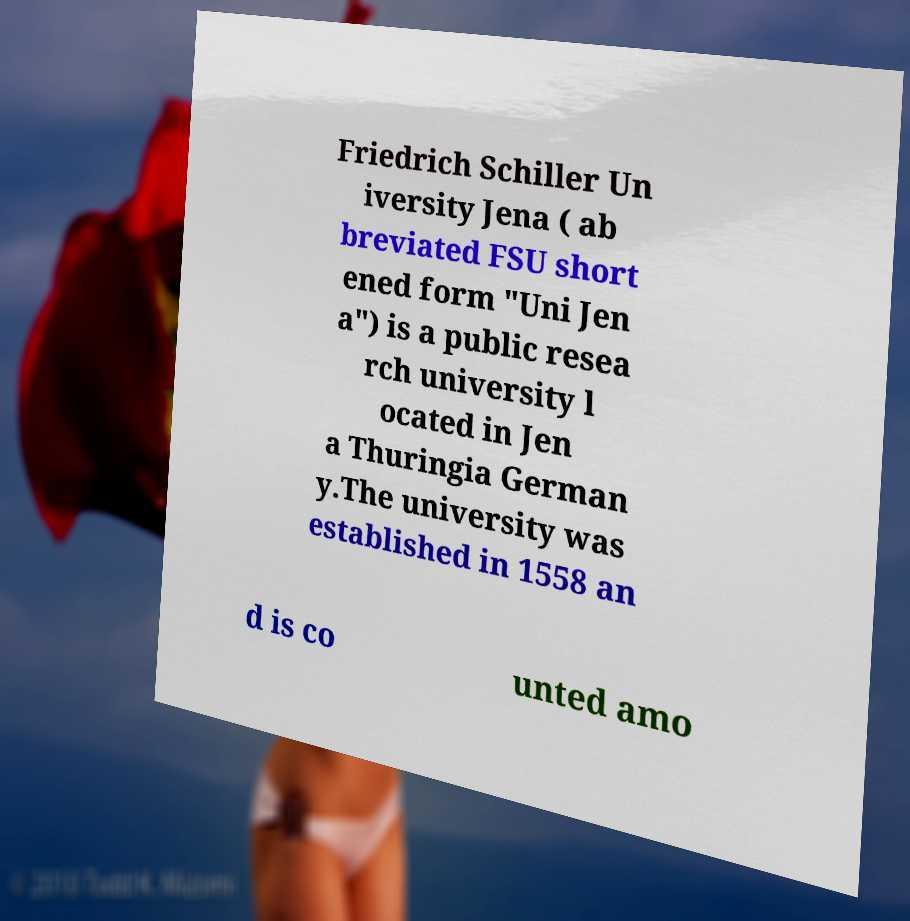Could you assist in decoding the text presented in this image and type it out clearly? Friedrich Schiller Un iversity Jena ( ab breviated FSU short ened form "Uni Jen a") is a public resea rch university l ocated in Jen a Thuringia German y.The university was established in 1558 an d is co unted amo 